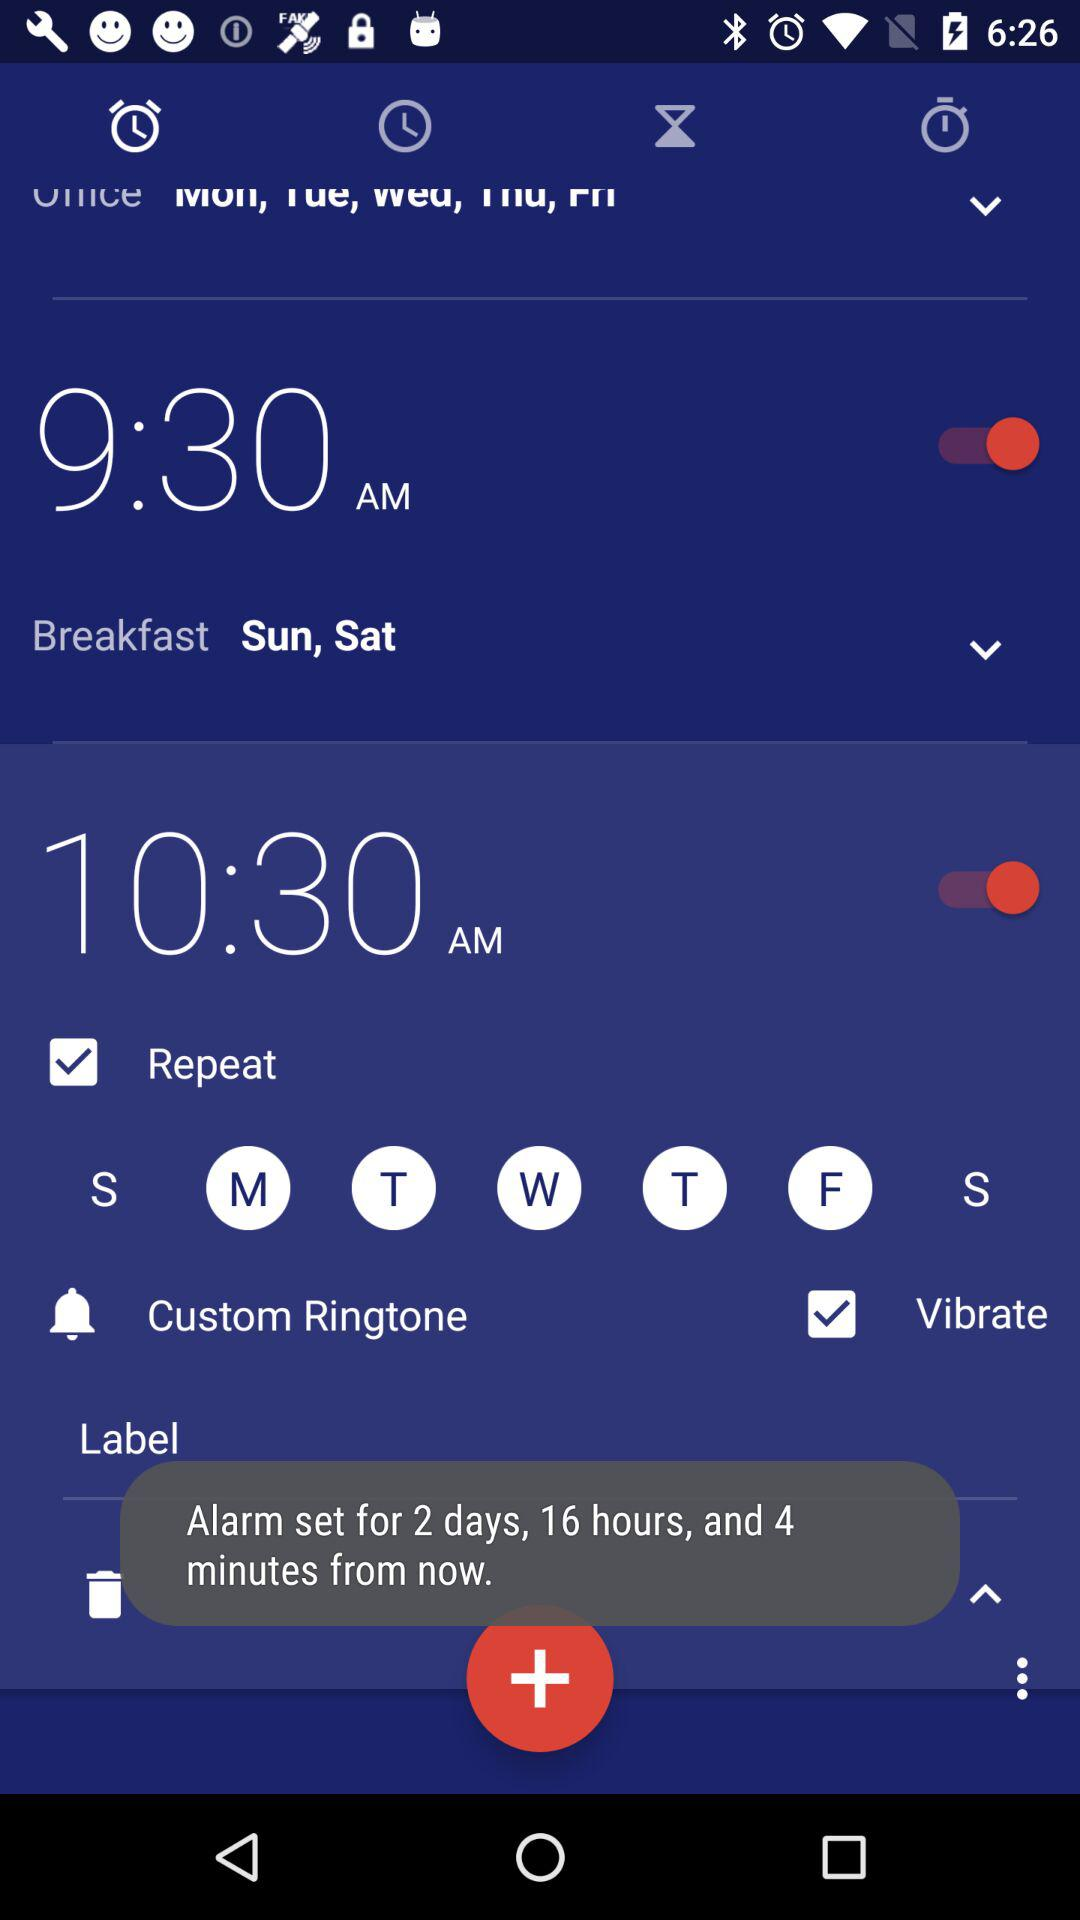What is the alarm start time?
When the provided information is insufficient, respond with <no answer>. <no answer> 